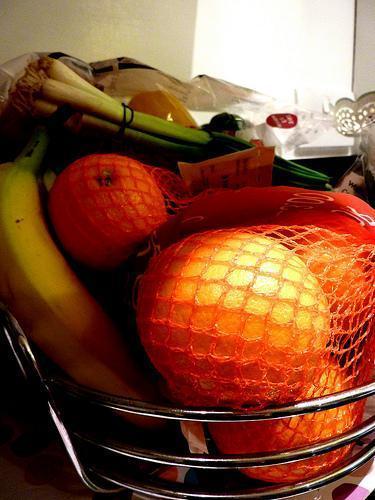How many bananas are visible?
Give a very brief answer. 1. 